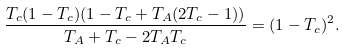Convert formula to latex. <formula><loc_0><loc_0><loc_500><loc_500>\frac { T _ { c } ( 1 - T _ { c } ) ( 1 - T _ { c } + T _ { A } ( 2 T _ { c } - 1 ) ) } { T _ { A } + T _ { c } - 2 T _ { A } T _ { c } } = ( 1 - T _ { c } ) ^ { 2 } .</formula> 